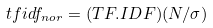<formula> <loc_0><loc_0><loc_500><loc_500>t f i d f _ { n o r } = ( T F . I D F ) ( N / \sigma )</formula> 